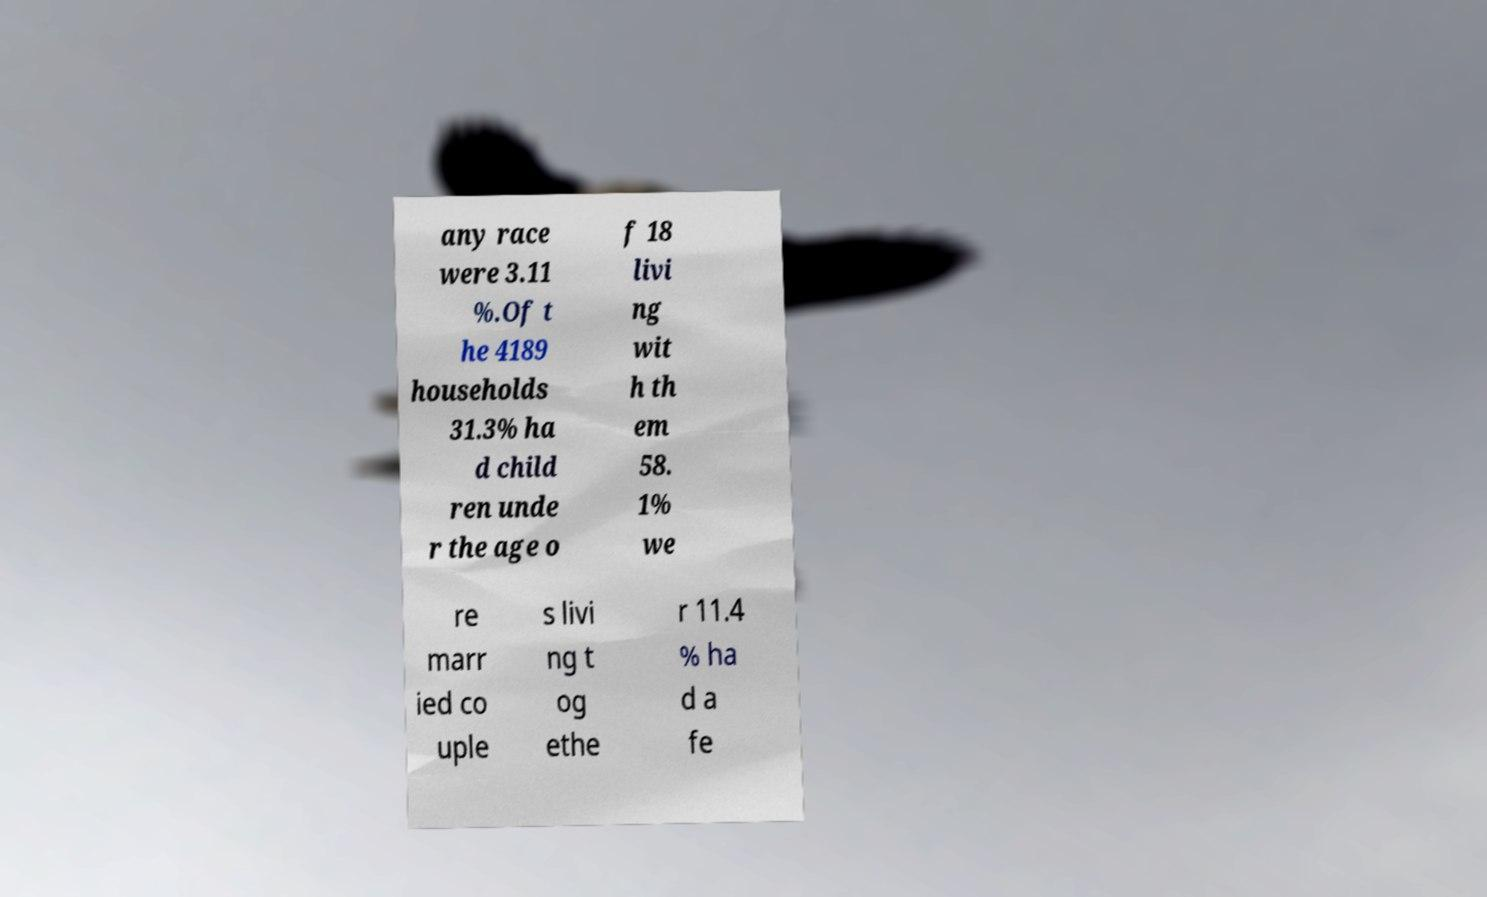I need the written content from this picture converted into text. Can you do that? any race were 3.11 %.Of t he 4189 households 31.3% ha d child ren unde r the age o f 18 livi ng wit h th em 58. 1% we re marr ied co uple s livi ng t og ethe r 11.4 % ha d a fe 